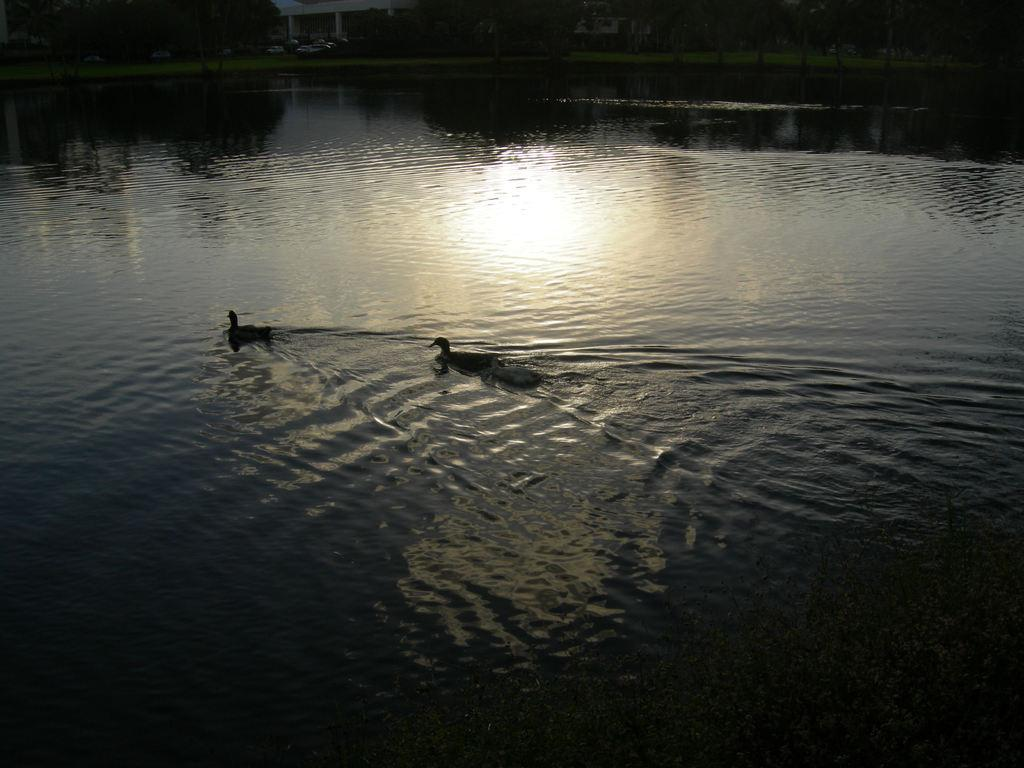What type of animals are in the water in the image? There are ducks in the water in the image. What can be seen in the background of the image? There are trees and a building in the background of the image. Where is the goat giving birth in the image? There is no goat or birth depicted in the image; it features ducks in the water and trees and a building in the background. 